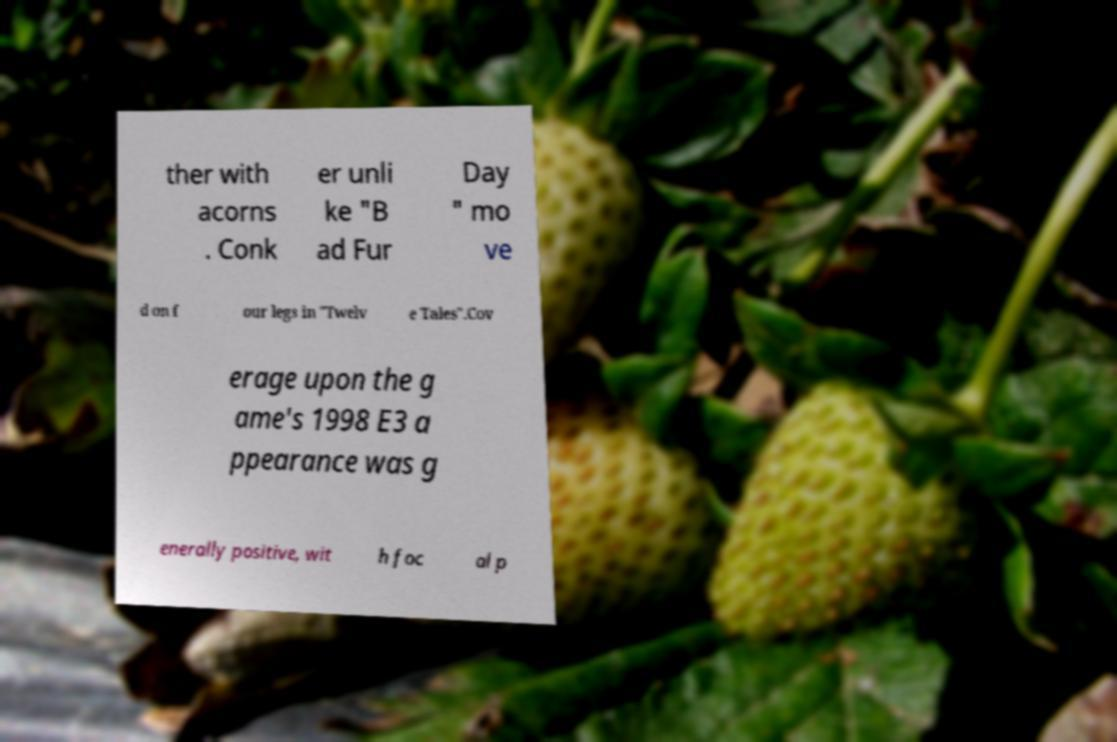What messages or text are displayed in this image? I need them in a readable, typed format. ther with acorns . Conk er unli ke "B ad Fur Day " mo ve d on f our legs in "Twelv e Tales".Cov erage upon the g ame's 1998 E3 a ppearance was g enerally positive, wit h foc al p 